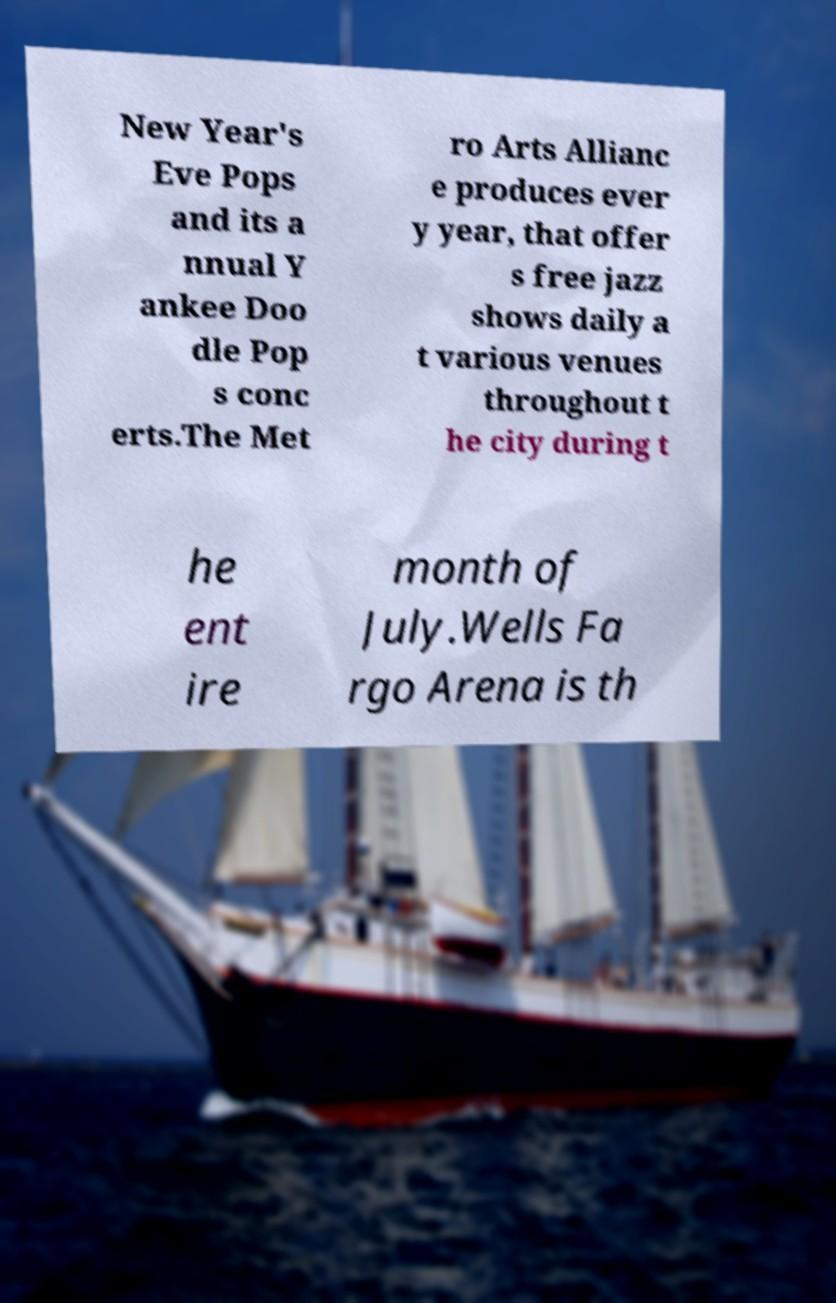What messages or text are displayed in this image? I need them in a readable, typed format. New Year's Eve Pops and its a nnual Y ankee Doo dle Pop s conc erts.The Met ro Arts Allianc e produces ever y year, that offer s free jazz shows daily a t various venues throughout t he city during t he ent ire month of July.Wells Fa rgo Arena is th 